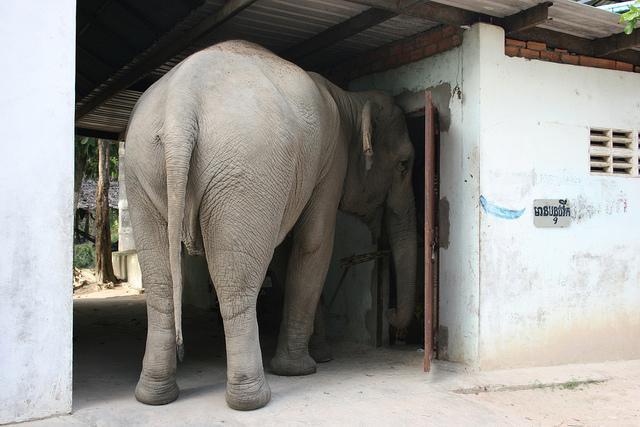How many cars are to the right?
Give a very brief answer. 0. 